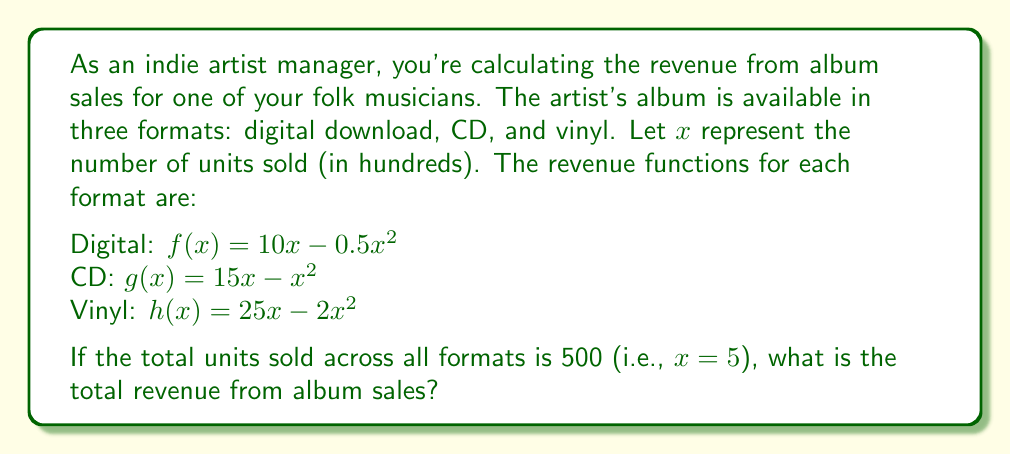Show me your answer to this math problem. To solve this problem, we need to follow these steps:

1. Evaluate each revenue function at $x = 5$:

   For digital downloads:
   $f(5) = 10(5) - 0.5(5^2) = 50 - 0.5(25) = 50 - 12.5 = 37.5$

   For CDs:
   $g(5) = 15(5) - (5^2) = 75 - 25 = 50$

   For vinyl:
   $h(5) = 25(5) - 2(5^2) = 125 - 2(25) = 125 - 50 = 75$

2. Sum up the revenues from all three formats:

   Total Revenue = $f(5) + g(5) + h(5)$
                 = $37.5 + 50 + 75$
                 = $162.5$

3. Since $x$ represents hundreds of units, we need to multiply the result by 100:

   Final Total Revenue = $162.5 * 100 = 16,250$

Therefore, the total revenue from album sales across all formats is $16,250.
Answer: $16,250 